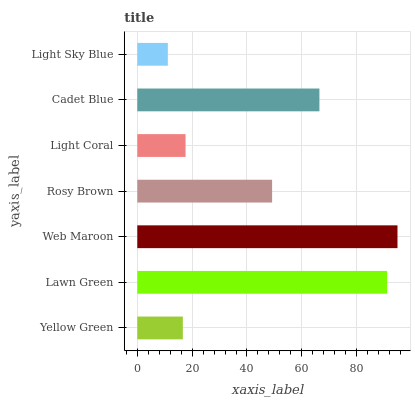Is Light Sky Blue the minimum?
Answer yes or no. Yes. Is Web Maroon the maximum?
Answer yes or no. Yes. Is Lawn Green the minimum?
Answer yes or no. No. Is Lawn Green the maximum?
Answer yes or no. No. Is Lawn Green greater than Yellow Green?
Answer yes or no. Yes. Is Yellow Green less than Lawn Green?
Answer yes or no. Yes. Is Yellow Green greater than Lawn Green?
Answer yes or no. No. Is Lawn Green less than Yellow Green?
Answer yes or no. No. Is Rosy Brown the high median?
Answer yes or no. Yes. Is Rosy Brown the low median?
Answer yes or no. Yes. Is Cadet Blue the high median?
Answer yes or no. No. Is Light Sky Blue the low median?
Answer yes or no. No. 